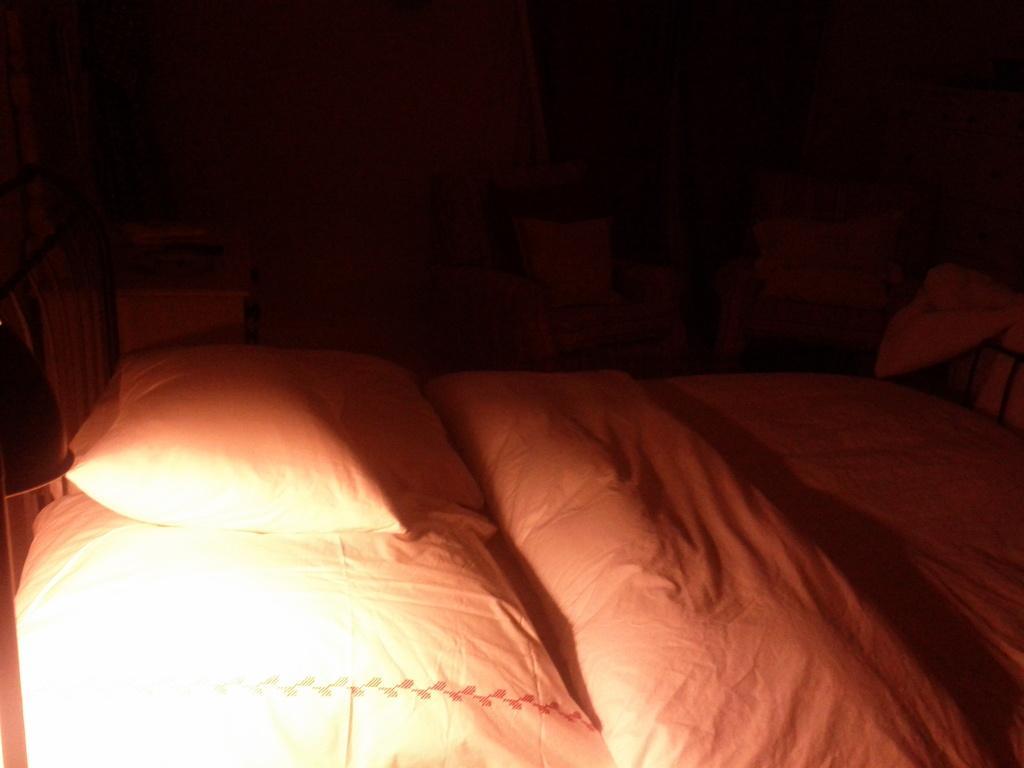Describe this image in one or two sentences. In this picture, we see a bed, white pillows and a blanket in white color. Behind the bed, we see the chairs and the pillows. On the left side, we see a table. In the left bottom, we see a lamp. In the background, we see a wall and the windows. This picture might be clicked in the dark. 